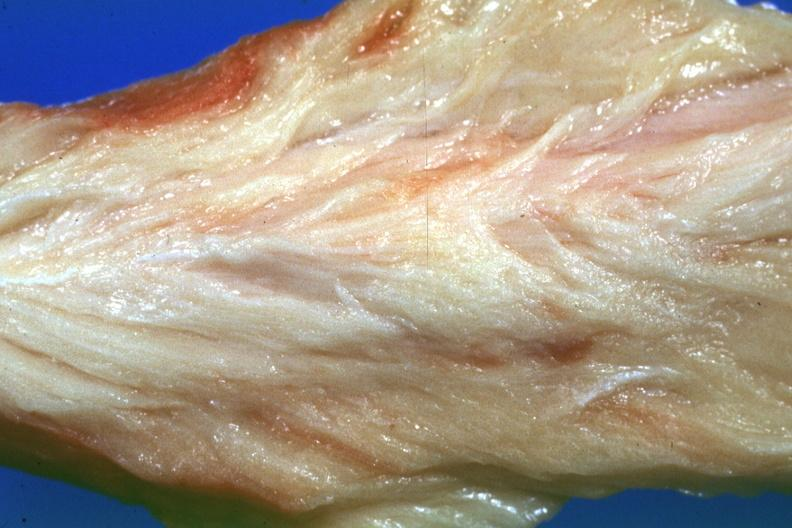what is present?
Answer the question using a single word or phrase. Soft tissue 